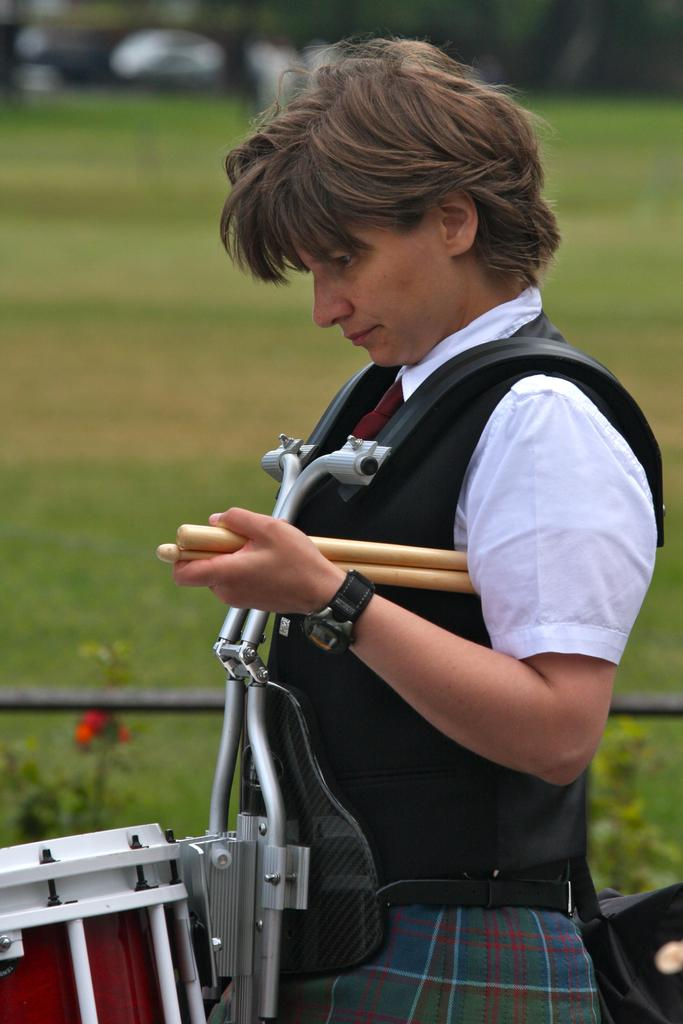What is present in the image? There is a person in the image. What is the person holding in her hand? The person is holding sticks in her hand. What can be seen in the background of the image? There is grass, the ground, and trees in the background of the image. What type of cart is being pulled by the person in the image? There is no cart present in the image; the person is holding sticks. 